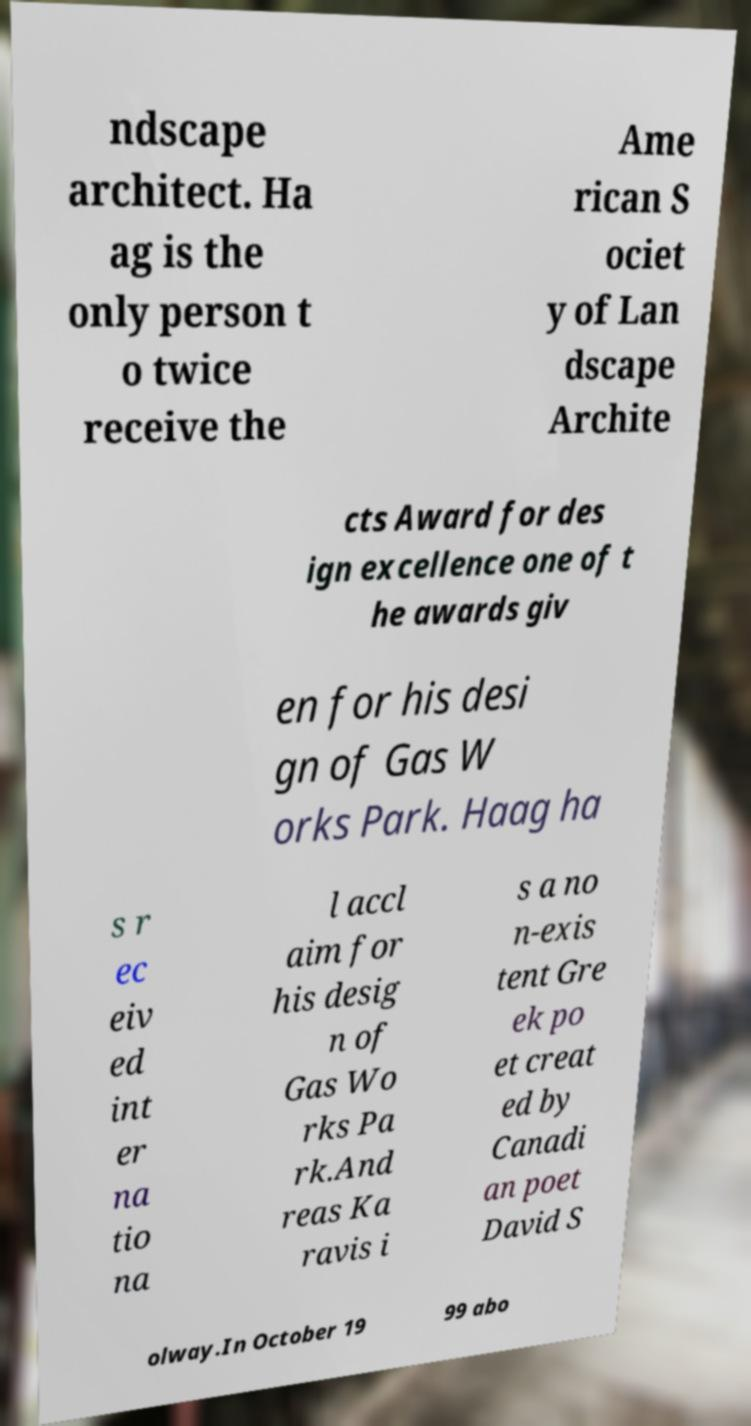I need the written content from this picture converted into text. Can you do that? ndscape architect. Ha ag is the only person t o twice receive the Ame rican S ociet y of Lan dscape Archite cts Award for des ign excellence one of t he awards giv en for his desi gn of Gas W orks Park. Haag ha s r ec eiv ed int er na tio na l accl aim for his desig n of Gas Wo rks Pa rk.And reas Ka ravis i s a no n-exis tent Gre ek po et creat ed by Canadi an poet David S olway.In October 19 99 abo 